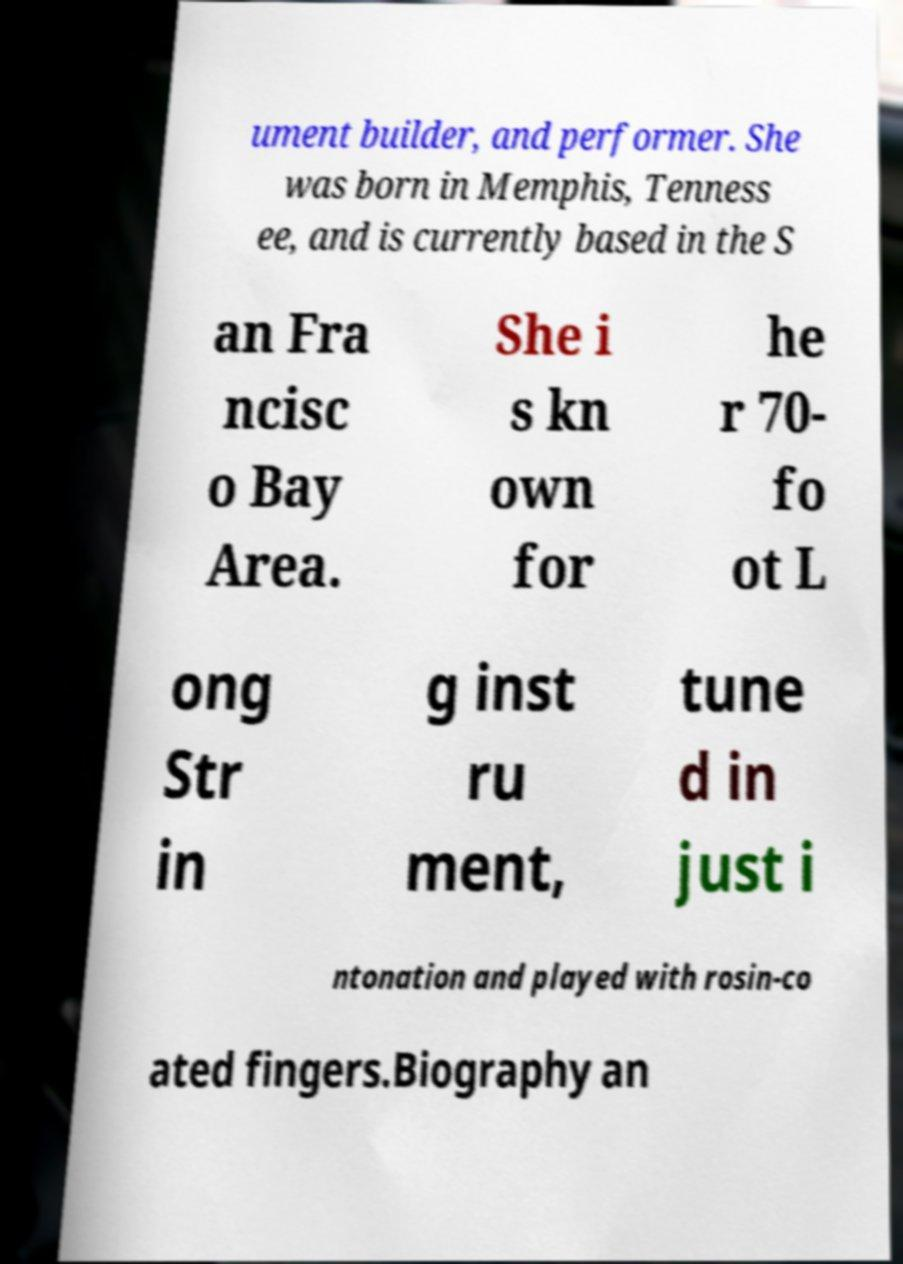Please identify and transcribe the text found in this image. ument builder, and performer. She was born in Memphis, Tenness ee, and is currently based in the S an Fra ncisc o Bay Area. She i s kn own for he r 70- fo ot L ong Str in g inst ru ment, tune d in just i ntonation and played with rosin-co ated fingers.Biography an 